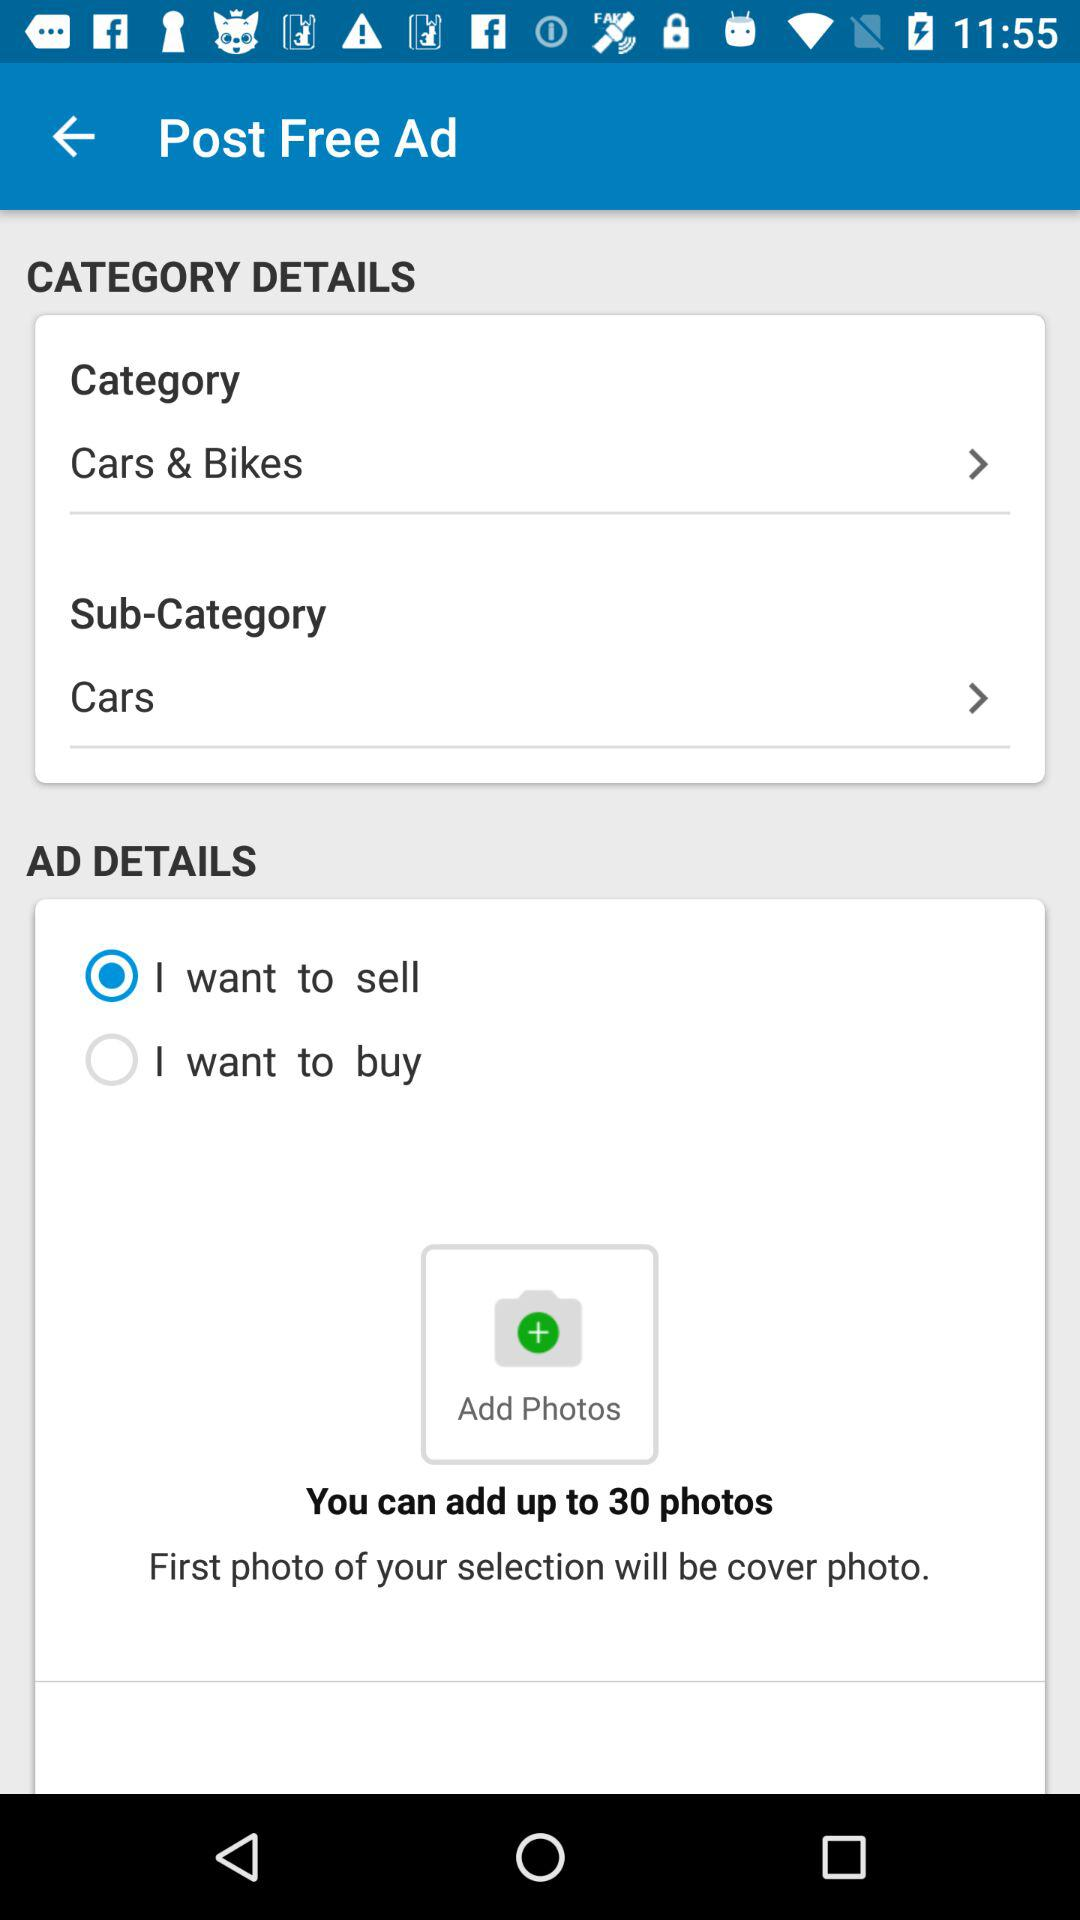How many photos can you add up to? You can add up to 30 photos. 